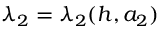<formula> <loc_0><loc_0><loc_500><loc_500>\lambda _ { 2 } = \lambda _ { 2 } ( h , a _ { 2 } )</formula> 